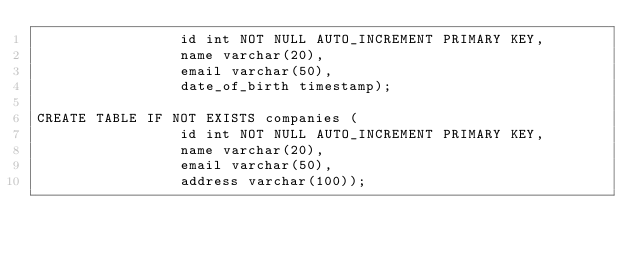Convert code to text. <code><loc_0><loc_0><loc_500><loc_500><_SQL_>                 id int NOT NULL AUTO_INCREMENT PRIMARY KEY,
                 name varchar(20),
                 email varchar(50),
                 date_of_birth timestamp);

CREATE TABLE IF NOT EXISTS companies (
                 id int NOT NULL AUTO_INCREMENT PRIMARY KEY,
                 name varchar(20),
                 email varchar(50),
                 address varchar(100));
</code> 